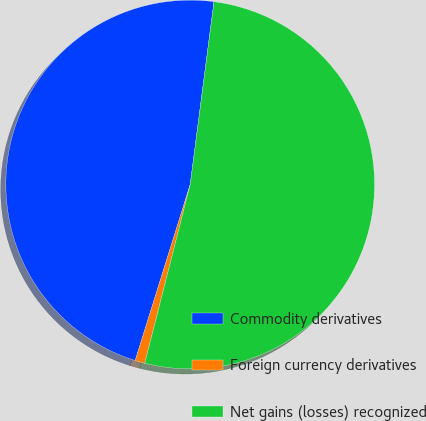Convert chart to OTSL. <chart><loc_0><loc_0><loc_500><loc_500><pie_chart><fcel>Commodity derivatives<fcel>Foreign currency derivatives<fcel>Net gains (losses) recognized<nl><fcel>47.24%<fcel>0.86%<fcel>51.9%<nl></chart> 